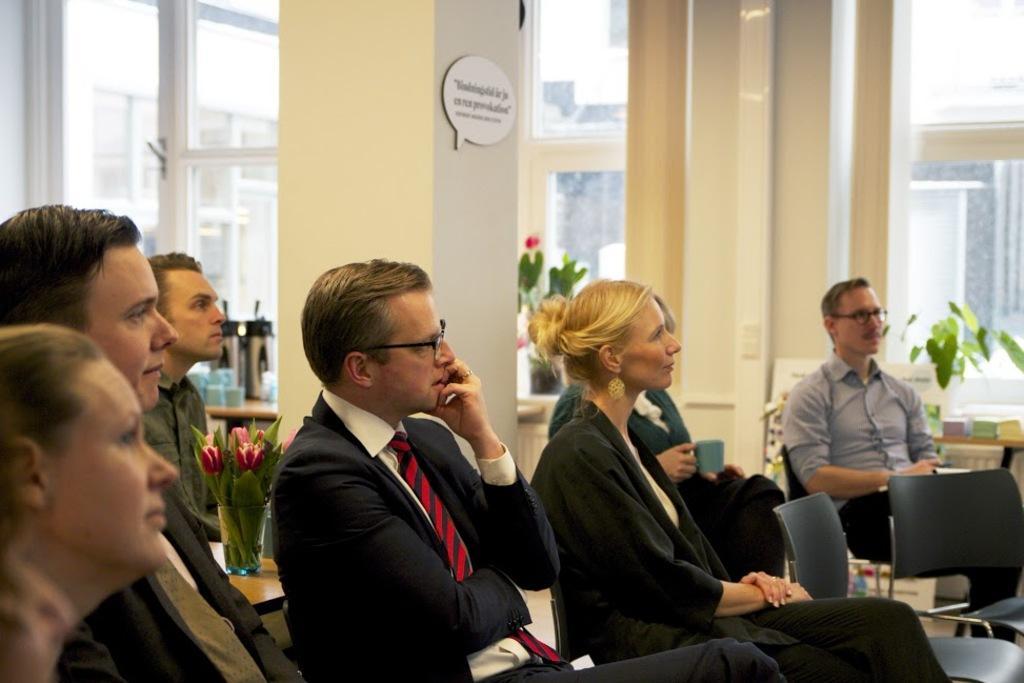Could you give a brief overview of what you see in this image? In the foreground I can see a group of people are sitting on the chairs. In the background I can see houseplants, pillars, wall, glass windows and buildings. This image is taken may be in a hall. 